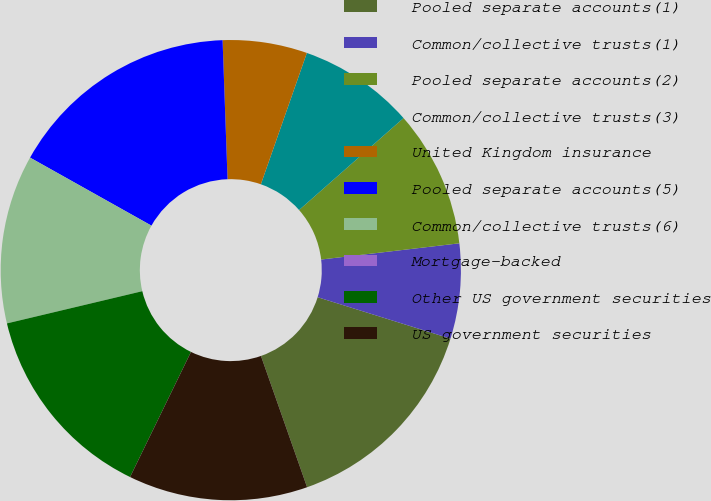Convert chart. <chart><loc_0><loc_0><loc_500><loc_500><pie_chart><fcel>Pooled separate accounts(1)<fcel>Common/collective trusts(1)<fcel>Pooled separate accounts(2)<fcel>Common/collective trusts(3)<fcel>United Kingdom insurance<fcel>Pooled separate accounts(5)<fcel>Common/collective trusts(6)<fcel>Mortgage-backed<fcel>Other US government securities<fcel>US government securities<nl><fcel>14.81%<fcel>6.67%<fcel>9.63%<fcel>8.15%<fcel>5.93%<fcel>16.3%<fcel>11.85%<fcel>0.0%<fcel>14.07%<fcel>12.59%<nl></chart> 